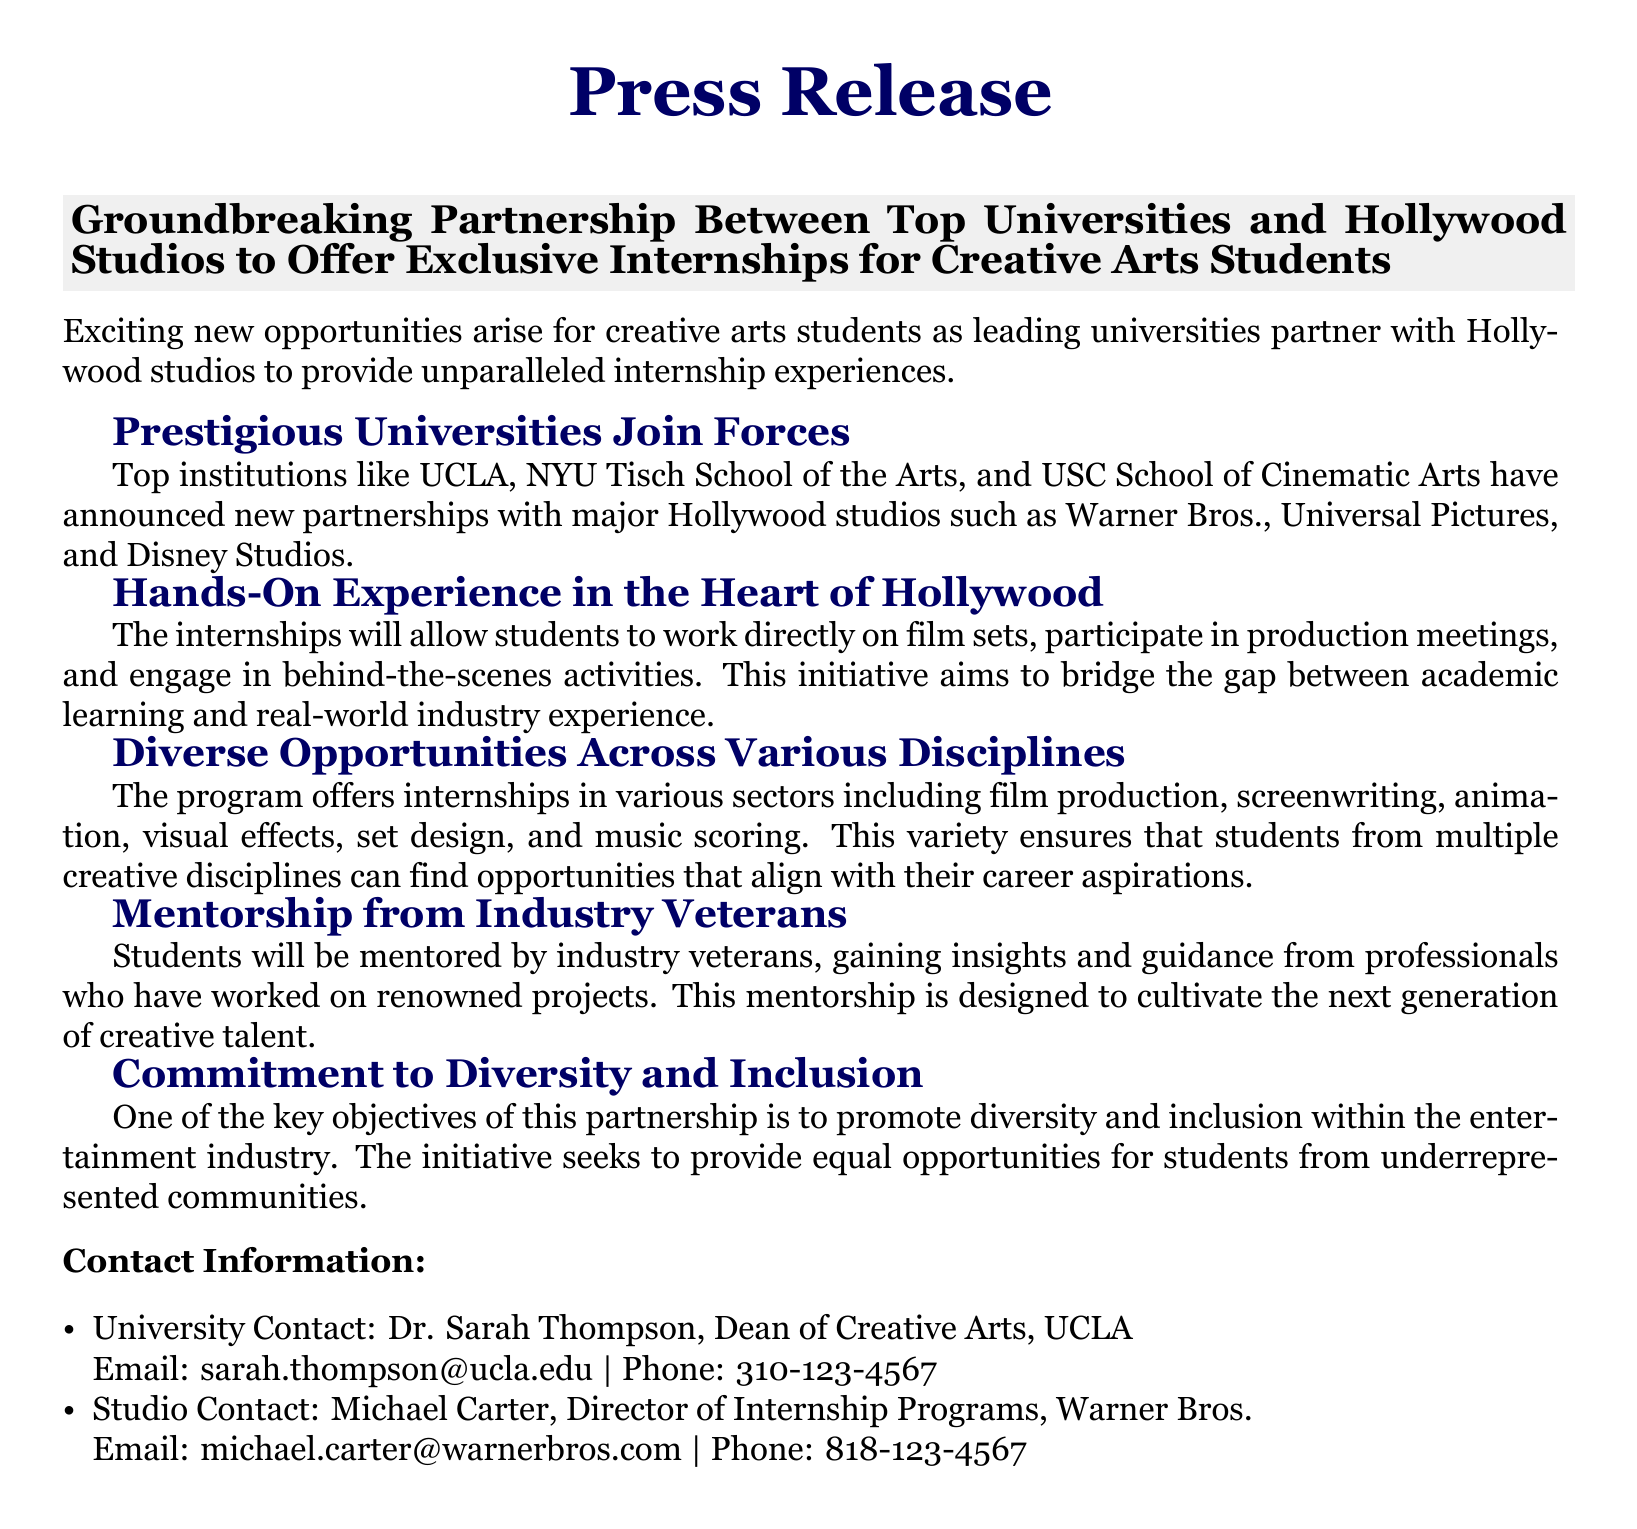What are the names of the prestigious universities involved? The document lists universities such as UCLA, NYU Tisch School of the Arts, and USC School of Cinematic Arts as participants in the partnership.
Answer: UCLA, NYU Tisch School of the Arts, USC School of Cinematic Arts Which studios are partnering with the universities? Major Hollywood studios mentioned in the document include Warner Bros., Universal Pictures, and Disney Studios.
Answer: Warner Bros., Universal Pictures, Disney Studios What types of internships are offered through this program? The document specifies internships in film production, screenwriting, animation, visual effects, set design, and music scoring.
Answer: Film production, screenwriting, animation, visual effects, set design, music scoring Who is the contact person from UCLA? Dr. Sarah Thompson is identified as the Dean of Creative Arts at UCLA and the university contact in the document.
Answer: Dr. Sarah Thompson What is one of the key objectives of the partnership? The document mentions that promoting diversity and inclusion within the entertainment industry is a key objective of the partnership.
Answer: Diversity and inclusion What kind of experience will students gain? Students will work directly on film sets, participate in production meetings, and engage in behind-the-scenes activities.
Answer: Hands-on experience How will students be supported during their internships? The document explains that students will be mentored by industry veterans who have worked on renowned projects, providing them with valuable insights and guidance.
Answer: Mentorship from industry veterans What is the primary focus of the press release? The press release announces a partnership between universities and Hollywood studios focusing on internship opportunities for creative arts students.
Answer: Partnership for internships 